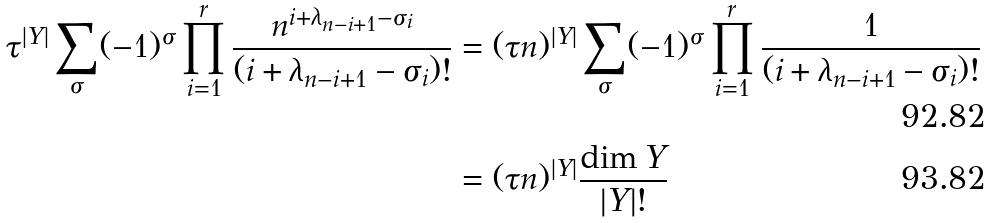Convert formula to latex. <formula><loc_0><loc_0><loc_500><loc_500>\tau ^ { | Y | } \sum _ { \sigma } ( - 1 ) ^ { \sigma } \prod _ { i = 1 } ^ { r } \frac { n ^ { i + \lambda _ { n - i + 1 } - \sigma _ { i } } } { ( i + \lambda _ { n - i + 1 } - \sigma _ { i } ) ! } & = ( \tau n ) ^ { | Y | } \sum _ { \sigma } ( - 1 ) ^ { \sigma } \prod _ { i = 1 } ^ { r } \frac { 1 } { ( i + \lambda _ { n - i + 1 } - \sigma _ { i } ) ! } \\ & = ( \tau n ) ^ { | Y | } \frac { \dim Y } { | Y | ! }</formula> 